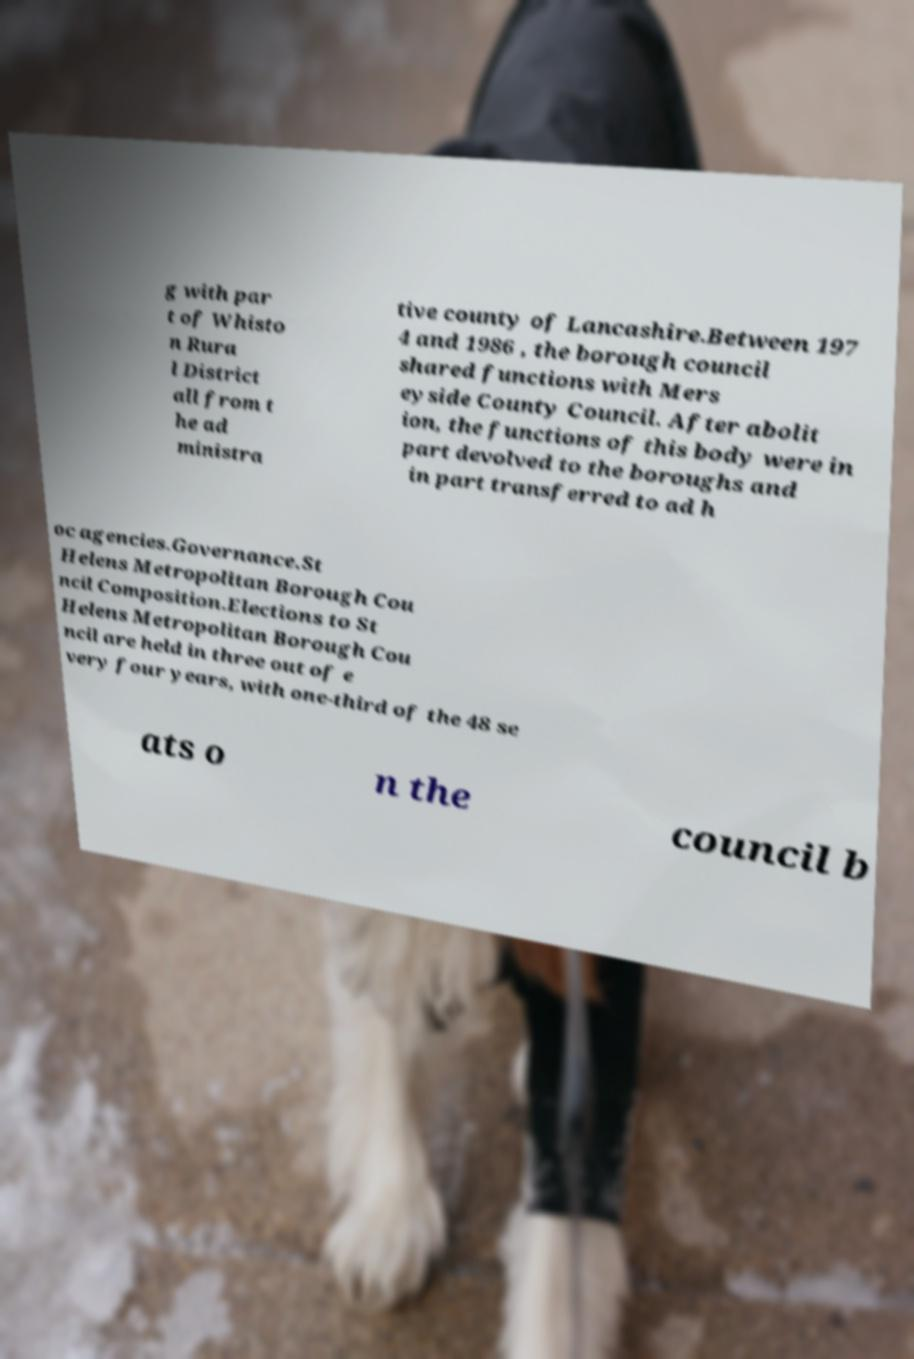Could you assist in decoding the text presented in this image and type it out clearly? g with par t of Whisto n Rura l District all from t he ad ministra tive county of Lancashire.Between 197 4 and 1986 , the borough council shared functions with Mers eyside County Council. After abolit ion, the functions of this body were in part devolved to the boroughs and in part transferred to ad h oc agencies.Governance.St Helens Metropolitan Borough Cou ncil Composition.Elections to St Helens Metropolitan Borough Cou ncil are held in three out of e very four years, with one-third of the 48 se ats o n the council b 